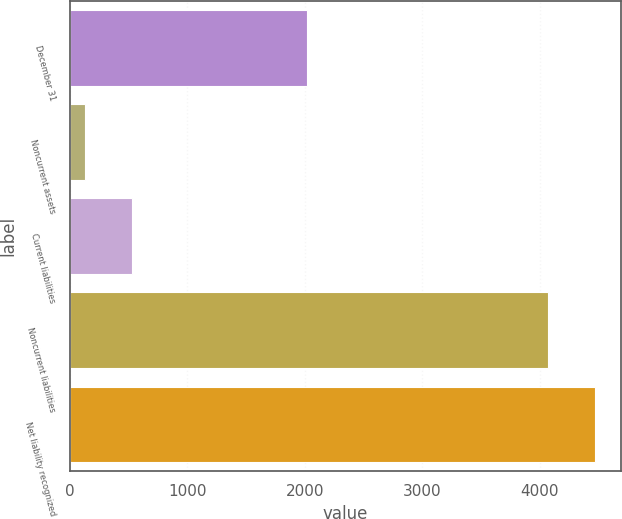<chart> <loc_0><loc_0><loc_500><loc_500><bar_chart><fcel>December 31<fcel>Noncurrent assets<fcel>Current liabilities<fcel>Noncurrent liabilities<fcel>Net liability recognized<nl><fcel>2017<fcel>133<fcel>527.9<fcel>4070<fcel>4464.9<nl></chart> 